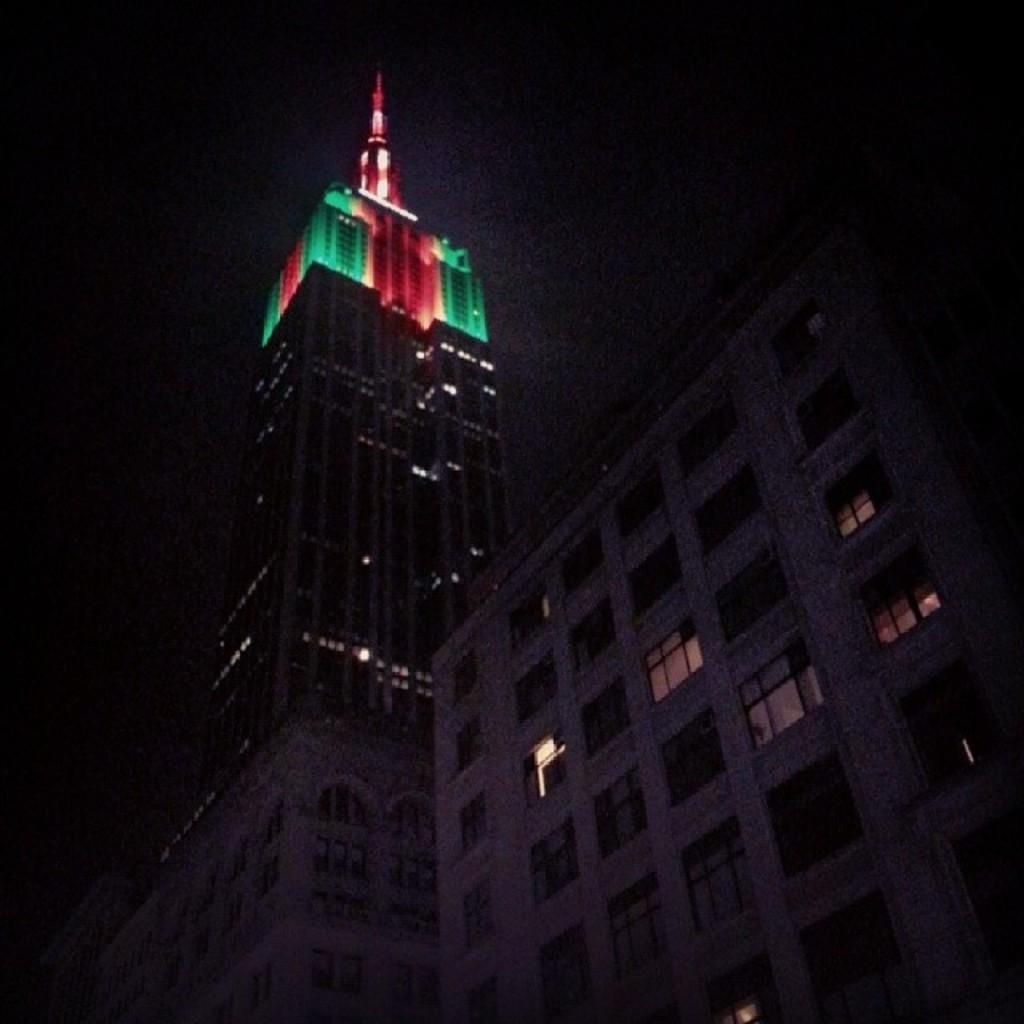What type of structure is visible in the image? There is a building in the image. What other feature can be seen on the building? There is a tower in the image. What can be seen illuminating the building? There are lights in the image. What architectural elements are present on the building? There are windows in the image. How would you describe the overall lighting in the image? The background of the image is dark. What type of desk can be seen in the image? There is no desk present in the image. What is the chalk used for in the image? There is no chalk present in the image. 